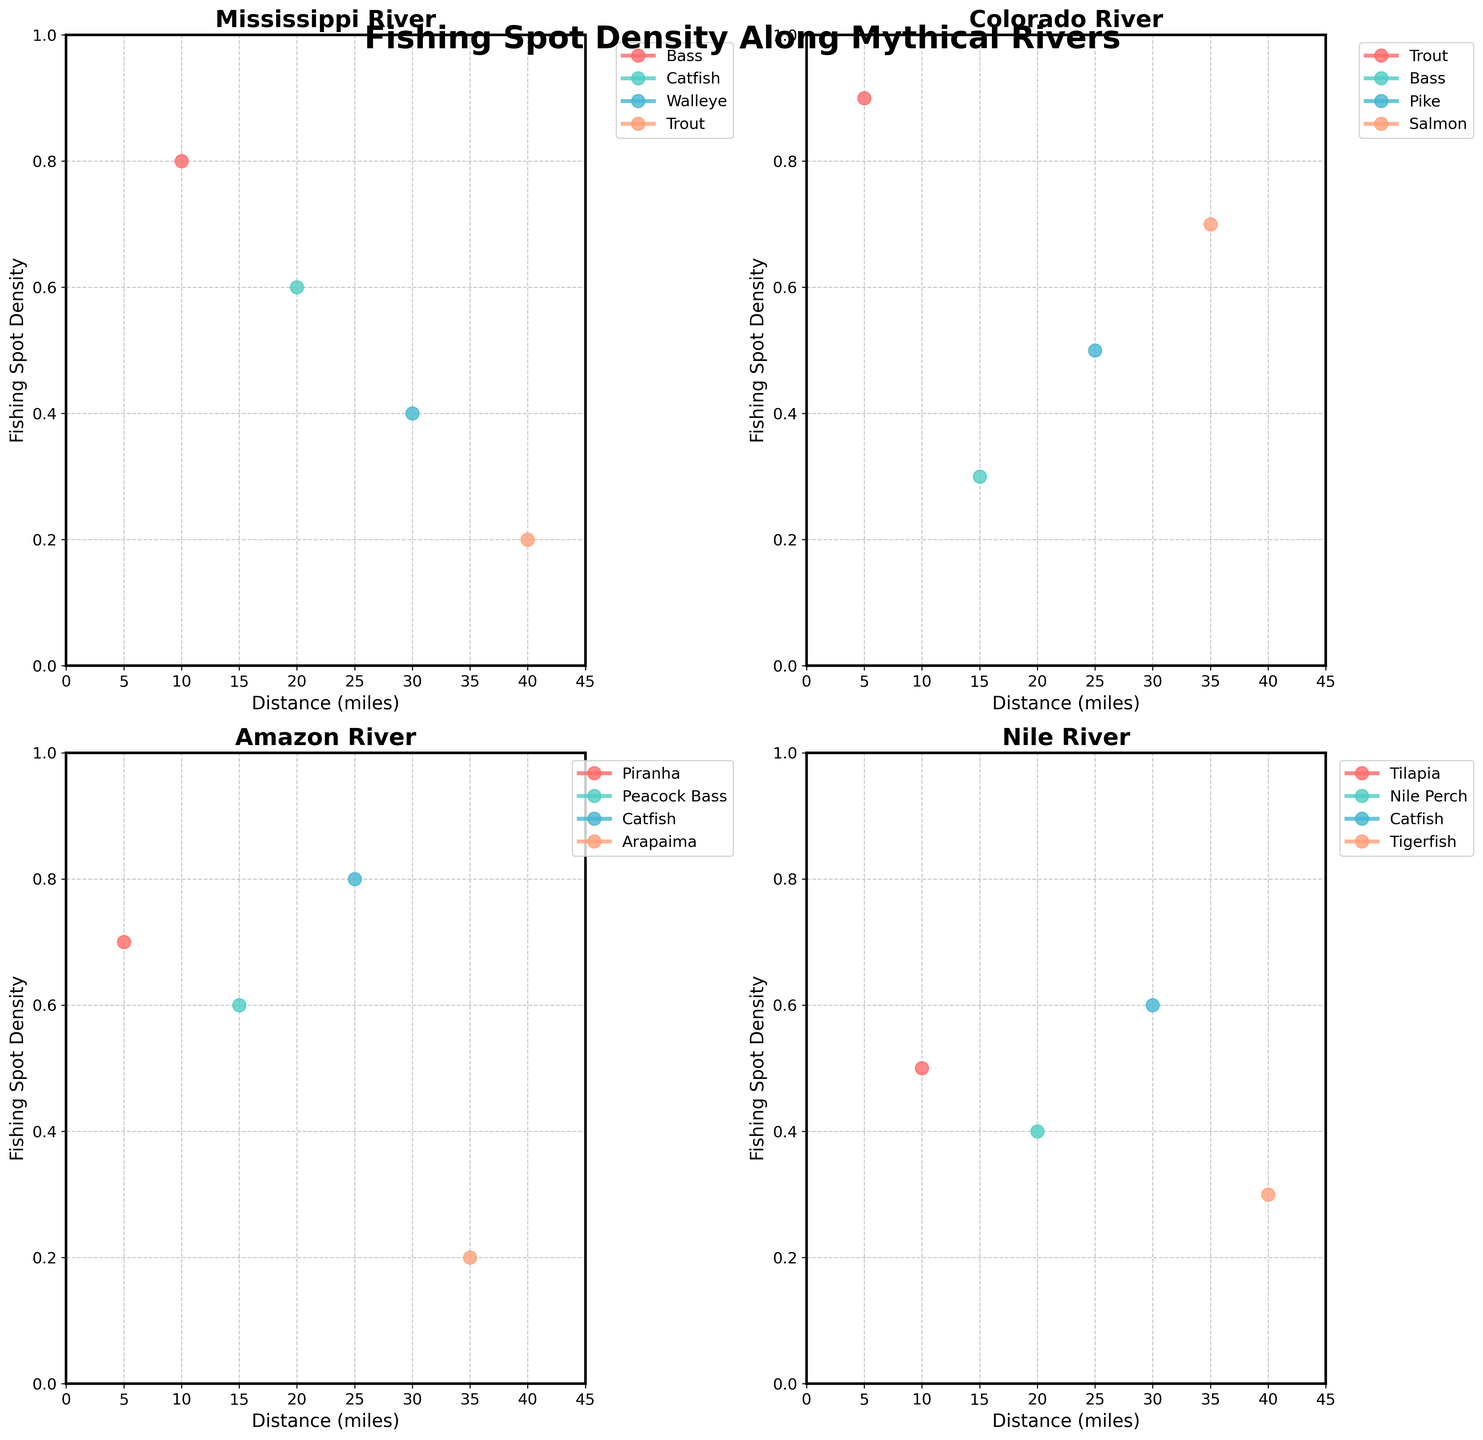What's the title of the figure? The title of the figure is displayed prominently at the top of the plot in a large font. It reads: "Fishing Spot Density Along Mythical Rivers".
Answer: Fishing Spot Density Along Mythical Rivers Which river shows the highest density for a single fish species? The Colorado River has the highest density for a single fish species. Specifically, Trout in the Colorado River shows a density of 0.9 at a distance of 5 miles.
Answer: Colorado River What is the density value for Piranha in the Amazon River? The density value can be found by locating the Piranha data points on the Amazon River subplot. The data shows that Piranha has a density of 0.7 at a distance of 5 miles.
Answer: 0.7 Which species has the lowest density in the Nile River? By comparing all the species densities in the Nile River subplot, it is clear that the Tigerfish has the lowest density, marked as 0.3 at 40 miles.
Answer: Tigerfish Compare the maximum density of Bass in the Mississippi and Colorado Rivers. Which one is higher? The subplot for the Mississippi shows Bass with a density of 0.8 at 10 miles, while the subplot for the Colorado shows Bass with a density of 0.3 at 15 miles. The density for Bass is higher in the Mississippi River.
Answer: Mississippi River What is the average density of species in the Mississippi River? To find the average density in the Mississippi River, sum the densities of all species (0.8, 0.6, 0.4, 0.2) and divide by the number of species. The sum is 2.0, and there are 4 species, so the average is 2.0 / 4 = 0.5.
Answer: 0.5 Which river has the most species with densities of 0.6 or higher? By analyzing each subplot, the Amazon River has three species (Piranha, Peacock Bass, and Catfish) with densities of 0.6 or higher. The other rivers do not have as many.
Answer: Amazon River How does the density of Arapaima in the Amazon River compare to that of Trout in the Mississippi River? The density of Arapaima in the Amazon River is 0.2 at 35 miles, whereas the density of Trout in the Mississippi River is also 0.2 at 40 miles. Thus, their densities are the same.
Answer: Same What is the total density value for all species in the Colorado River? Sum the individual densities for each species in the Colorado River (0.9, 0.3, 0.5, 0.7). The sum is 2.4.
Answer: 2.4 